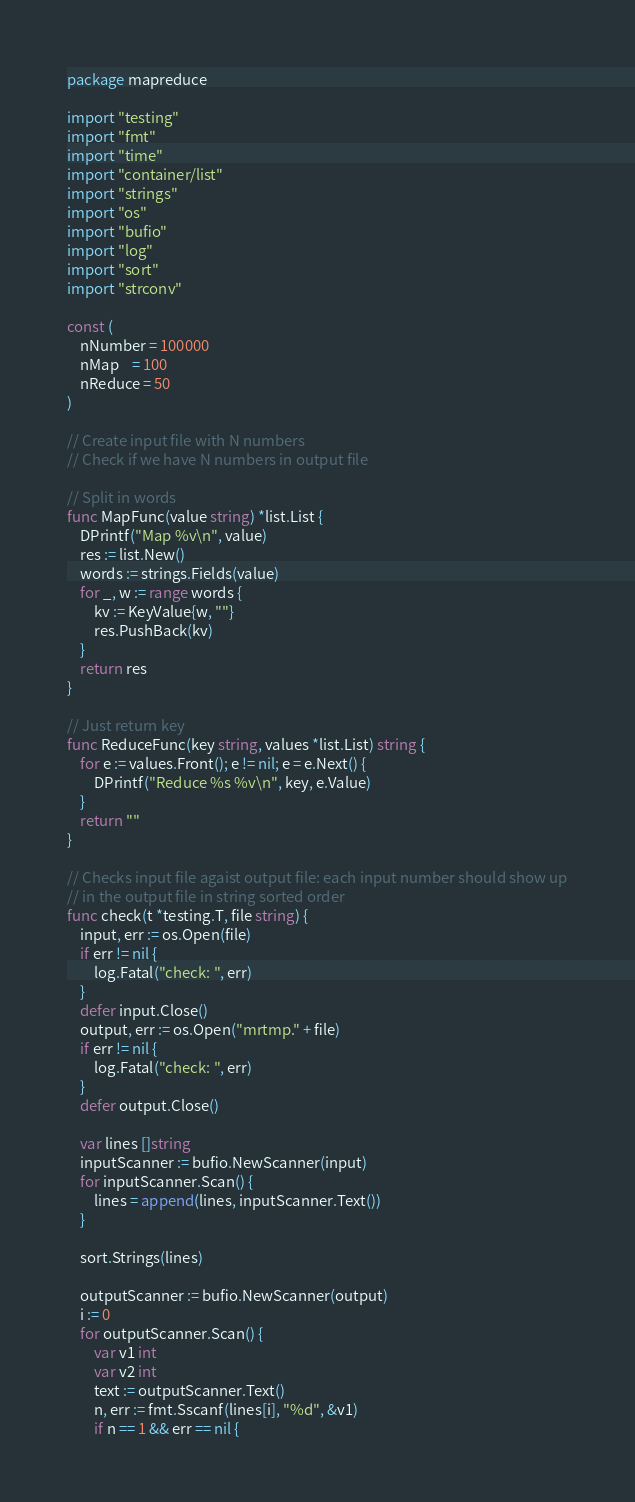Convert code to text. <code><loc_0><loc_0><loc_500><loc_500><_Go_>package mapreduce

import "testing"
import "fmt"
import "time"
import "container/list"
import "strings"
import "os"
import "bufio"
import "log"
import "sort"
import "strconv"

const (
	nNumber = 100000
	nMap    = 100
	nReduce = 50
)

// Create input file with N numbers
// Check if we have N numbers in output file

// Split in words
func MapFunc(value string) *list.List {
	DPrintf("Map %v\n", value)
	res := list.New()
	words := strings.Fields(value)
	for _, w := range words {
		kv := KeyValue{w, ""}
		res.PushBack(kv)
	}
	return res
}

// Just return key
func ReduceFunc(key string, values *list.List) string {
	for e := values.Front(); e != nil; e = e.Next() {
		DPrintf("Reduce %s %v\n", key, e.Value)
	}
	return ""
}

// Checks input file agaist output file: each input number should show up
// in the output file in string sorted order
func check(t *testing.T, file string) {
	input, err := os.Open(file)
	if err != nil {
		log.Fatal("check: ", err)
	}
	defer input.Close()
	output, err := os.Open("mrtmp." + file)
	if err != nil {
		log.Fatal("check: ", err)
	}
	defer output.Close()

	var lines []string
	inputScanner := bufio.NewScanner(input)
	for inputScanner.Scan() {
		lines = append(lines, inputScanner.Text())
	}

	sort.Strings(lines)

	outputScanner := bufio.NewScanner(output)
	i := 0
	for outputScanner.Scan() {
		var v1 int
		var v2 int
		text := outputScanner.Text()
		n, err := fmt.Sscanf(lines[i], "%d", &v1)
		if n == 1 && err == nil {</code> 